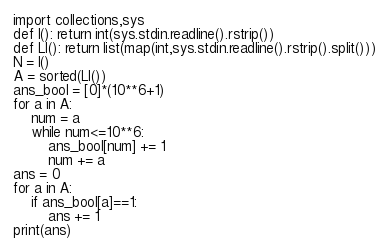Convert code to text. <code><loc_0><loc_0><loc_500><loc_500><_Python_>import collections,sys
def I(): return int(sys.stdin.readline().rstrip())
def LI(): return list(map(int,sys.stdin.readline().rstrip().split()))
N = I()
A = sorted(LI())
ans_bool = [0]*(10**6+1)
for a in A:
    num = a
    while num<=10**6:
        ans_bool[num] += 1
        num += a
ans = 0
for a in A:
    if ans_bool[a]==1:
        ans += 1
print(ans)
</code> 